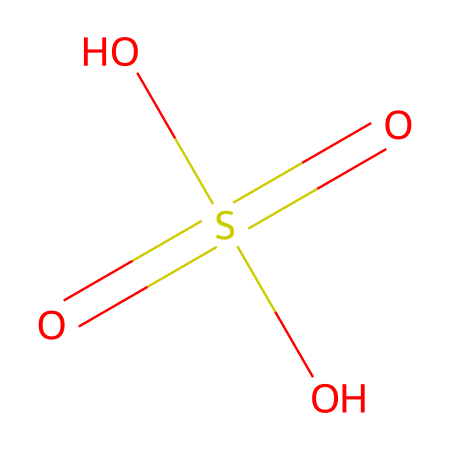What is the name of this chemical? The chemical structure depicted corresponds to sulfuric acid, which is characterized by its two sulfur-oxygen double bonds and two hydroxyl groups.
Answer: sulfuric acid How many oxygen atoms are present in this compound? The SMILES representation of sulfuric acid shows four oxygen atoms attached to the sulfur atom, two of which are part of hydroxyl groups, while the other two form double bonds.
Answer: four What is the oxidation state of sulfur in sulfuric acid? The oxidation state of sulfur in sulfuric acid can be found by analyzing the bonds: sulfur forms four bonds (two with oxygen in double bonds and two in hydroxyl groups), leading to an oxidation state of +6.
Answer: +6 What type of bonding is primarily present between sulfur and oxygen in this structure? The bonding between sulfur and oxygen in sulfuric acid includes both double bonds (between sulfur and two oxygen atoms) and single bonds (between sulfur and the hydroxyl groups).
Answer: covalent How does the presence of hydroxyl groups affect the properties of sulfuric acid? The hydroxyl groups in sulfuric acid contribute to its strong acidic properties by allowing it to donate protons, thus influencing its reactivity and applications in building materials.
Answer: increases acidity In what way do sulfur compounds like sulfuric acid contribute to the production of concrete? Sulfuric acid plays a role in the manufacturing of chemicals used to create ammonium sulfate, which acts as an additive in concrete mixtures to enhance durability.
Answer: chemical additive 